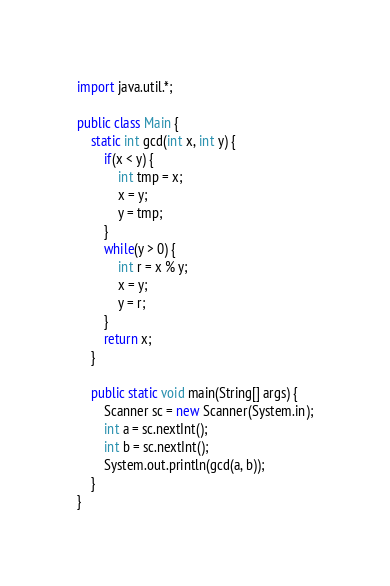<code> <loc_0><loc_0><loc_500><loc_500><_Java_>import java.util.*;

public class Main {
	static int gcd(int x, int y) {
		if(x < y) {
			int tmp = x;
			x = y;
			y = tmp;
		}
		while(y > 0) {
			int r = x % y;
			x = y;
			y = r;
		}
		return x;
	}
	
	public static void main(String[] args) {
		Scanner sc = new Scanner(System.in);
		int a = sc.nextInt();
		int b = sc.nextInt();
		System.out.println(gcd(a, b));
	}
}

</code> 